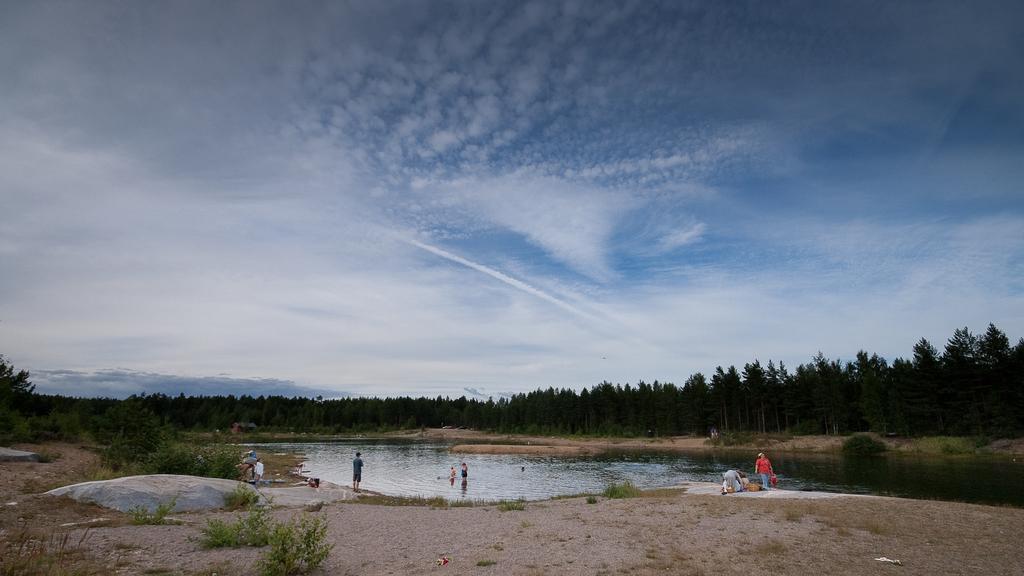How would you summarize this image in a sentence or two? This picture is clicked outside the city. In the center we can see the group of persons and a water body and some plants. In the background there is a sky and the trees. 